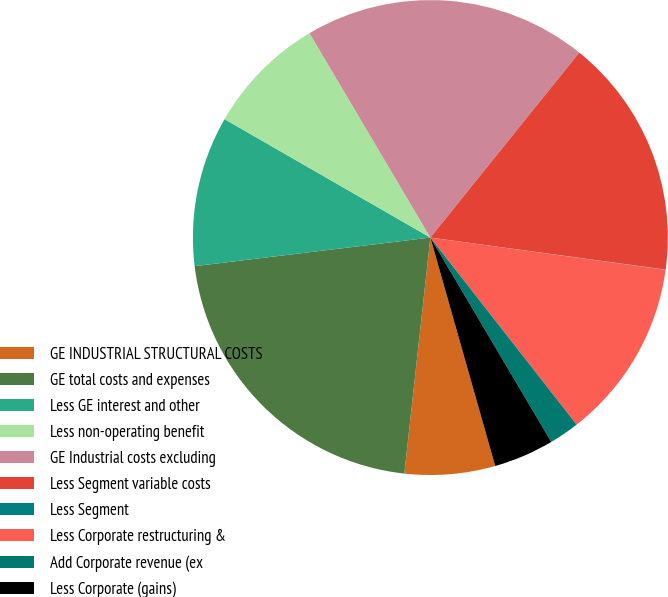Convert chart to OTSL. <chart><loc_0><loc_0><loc_500><loc_500><pie_chart><fcel>GE INDUSTRIAL STRUCTURAL COSTS<fcel>GE total costs and expenses<fcel>Less GE interest and other<fcel>Less non-operating benefit<fcel>GE Industrial costs excluding<fcel>Less Segment variable costs<fcel>Less Segment<fcel>Less Corporate restructuring &<fcel>Add Corporate revenue (ex<fcel>Less Corporate (gains)<nl><fcel>6.15%<fcel>21.33%<fcel>10.23%<fcel>8.19%<fcel>19.29%<fcel>16.36%<fcel>0.02%<fcel>12.27%<fcel>2.06%<fcel>4.1%<nl></chart> 